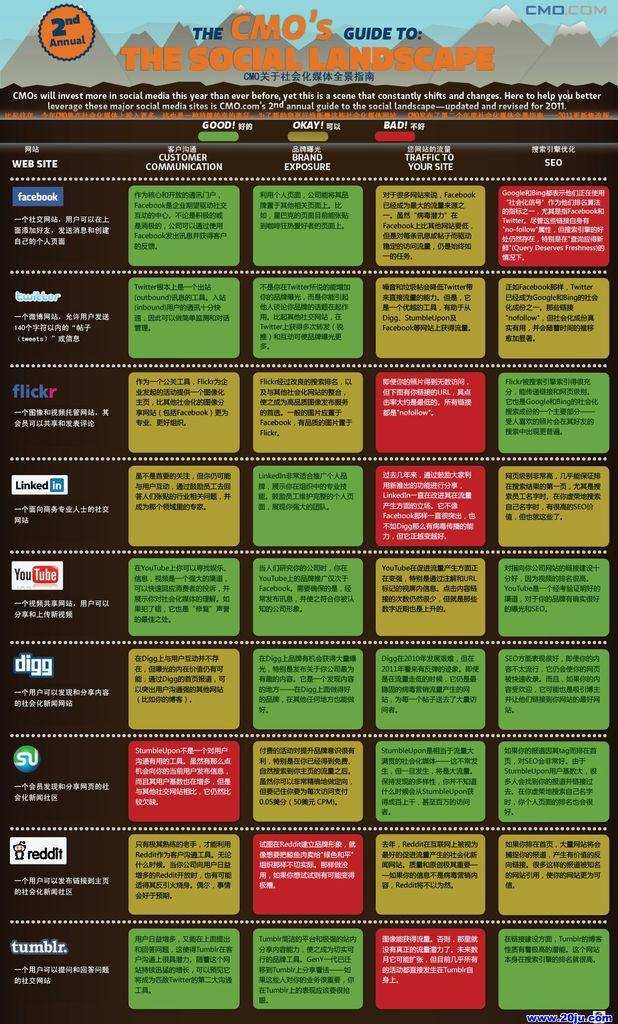<image>
Offer a succinct explanation of the picture presented. A big poster showing info about various social media platforms with the title of The CMO's Guide to the Social Landscape. 